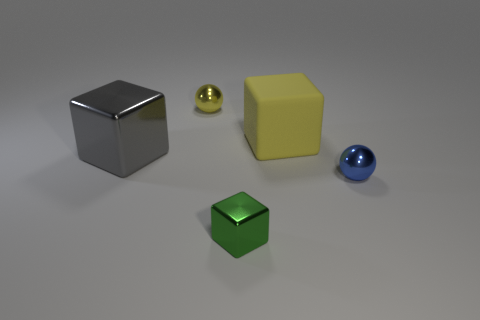What is the material of the gray block that is the same size as the yellow rubber block?
Ensure brevity in your answer.  Metal. Is the number of big metal cubes that are to the right of the yellow matte thing greater than the number of blue shiny spheres that are to the right of the green thing?
Ensure brevity in your answer.  No. Is there a cyan metal thing of the same shape as the blue object?
Provide a succinct answer. No. The object that is the same size as the gray metal cube is what shape?
Your response must be concise. Cube. There is a tiny thing in front of the blue shiny ball; what is its shape?
Your response must be concise. Cube. Are there fewer large yellow cubes right of the small blue ball than small yellow objects in front of the big rubber thing?
Keep it short and to the point. No. Is the size of the green metallic object the same as the gray block left of the green shiny thing?
Ensure brevity in your answer.  No. What number of blue metal spheres are the same size as the green thing?
Provide a succinct answer. 1. What color is the big thing that is made of the same material as the green block?
Your response must be concise. Gray. Is the number of red matte cubes greater than the number of big matte objects?
Provide a short and direct response. No. 